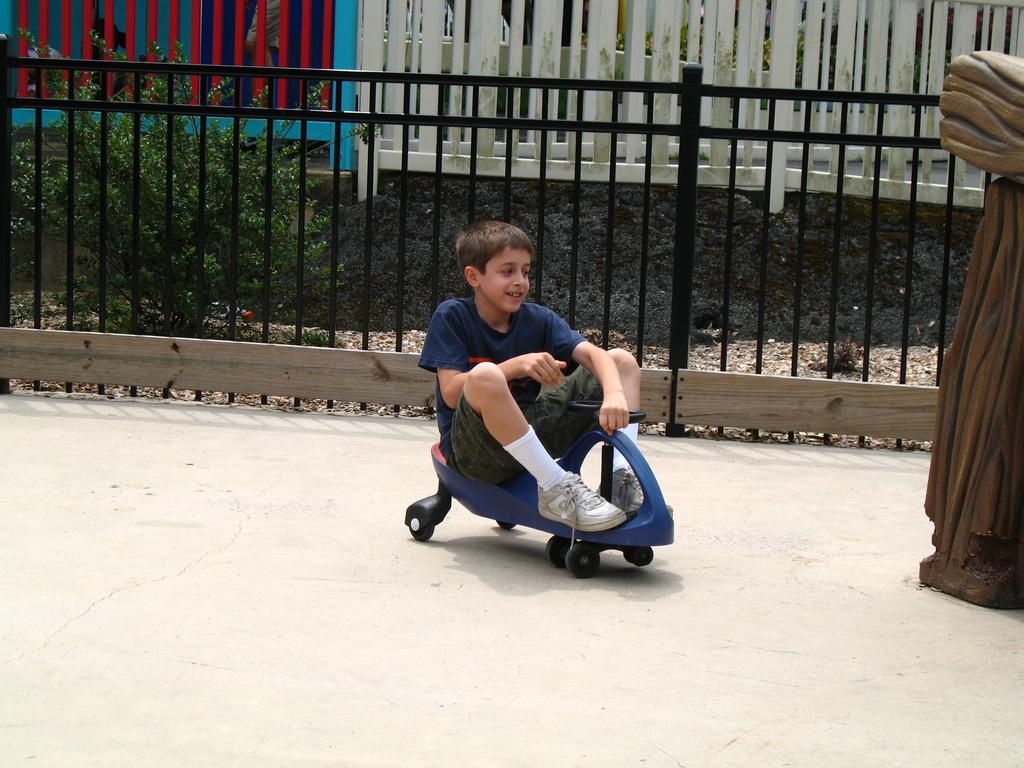What type of living organism can be seen in the image? There is a plant in the image. What structure is visible in the image? There is a fence in the image. What is the boy doing in the image? The boy is sitting on a toy car in the image. What type of scarf is the boy wearing in the image? There is no scarf present in the image; the boy is sitting on a toy car. What type of meat can be seen hanging from the fence in the image? There is no meat present in the image; the fence is not associated with any food items. 